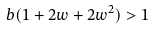<formula> <loc_0><loc_0><loc_500><loc_500>b ( 1 + 2 w + 2 w ^ { 2 } ) > 1</formula> 